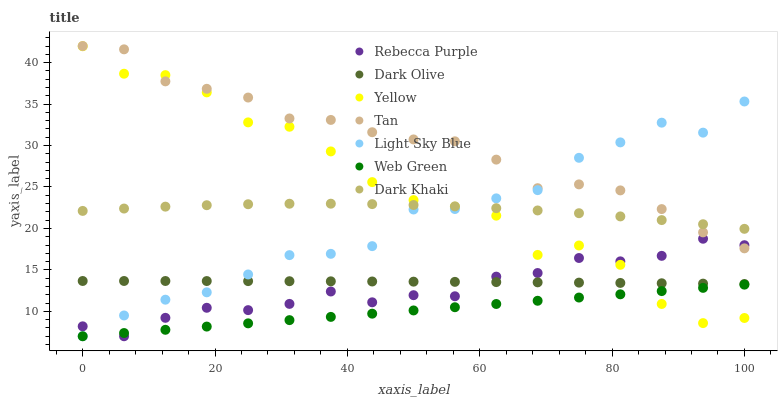Does Web Green have the minimum area under the curve?
Answer yes or no. Yes. Does Tan have the maximum area under the curve?
Answer yes or no. Yes. Does Dark Khaki have the minimum area under the curve?
Answer yes or no. No. Does Dark Khaki have the maximum area under the curve?
Answer yes or no. No. Is Web Green the smoothest?
Answer yes or no. Yes. Is Yellow the roughest?
Answer yes or no. Yes. Is Dark Khaki the smoothest?
Answer yes or no. No. Is Dark Khaki the roughest?
Answer yes or no. No. Does Web Green have the lowest value?
Answer yes or no. Yes. Does Dark Khaki have the lowest value?
Answer yes or no. No. Does Tan have the highest value?
Answer yes or no. Yes. Does Dark Khaki have the highest value?
Answer yes or no. No. Is Web Green less than Dark Khaki?
Answer yes or no. Yes. Is Dark Khaki greater than Dark Olive?
Answer yes or no. Yes. Does Dark Olive intersect Light Sky Blue?
Answer yes or no. Yes. Is Dark Olive less than Light Sky Blue?
Answer yes or no. No. Is Dark Olive greater than Light Sky Blue?
Answer yes or no. No. Does Web Green intersect Dark Khaki?
Answer yes or no. No. 